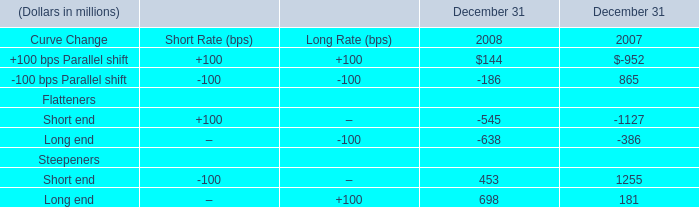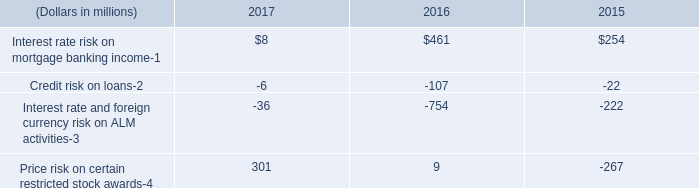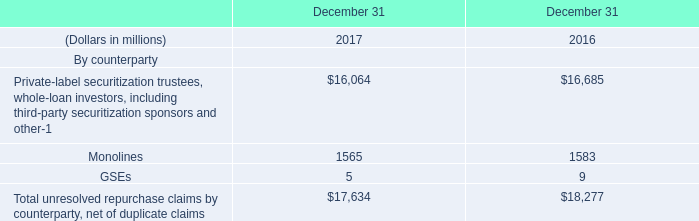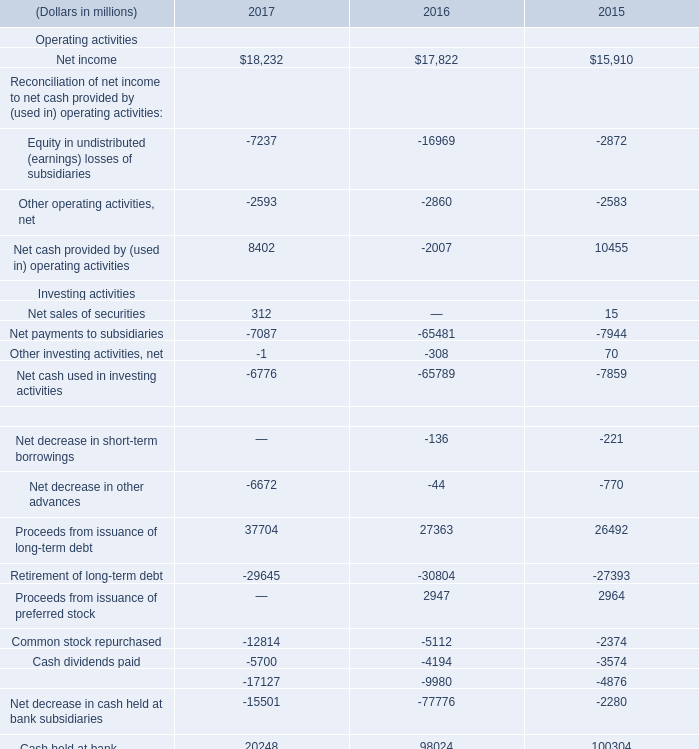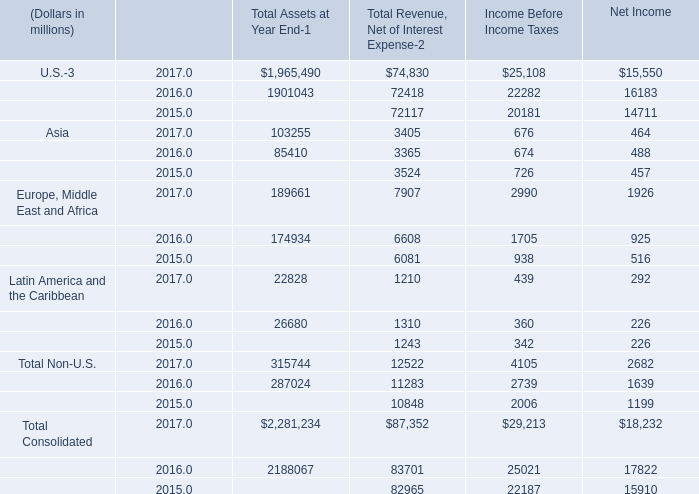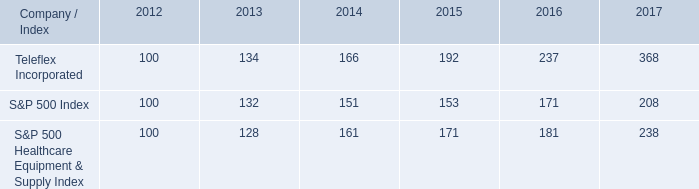What is the sum of Net payments to subsidiaries Investing activities of 2017, Short end Flatteners of December 31 2007, and Proceeds from issuance of preferred stock Financing activities of 2016 ? 
Computations: ((7087.0 + 1127.0) + 2947.0)
Answer: 11161.0. 